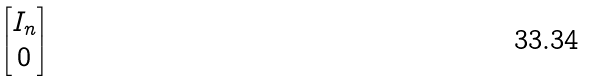Convert formula to latex. <formula><loc_0><loc_0><loc_500><loc_500>\begin{bmatrix} I _ { n } \\ 0 \end{bmatrix}</formula> 